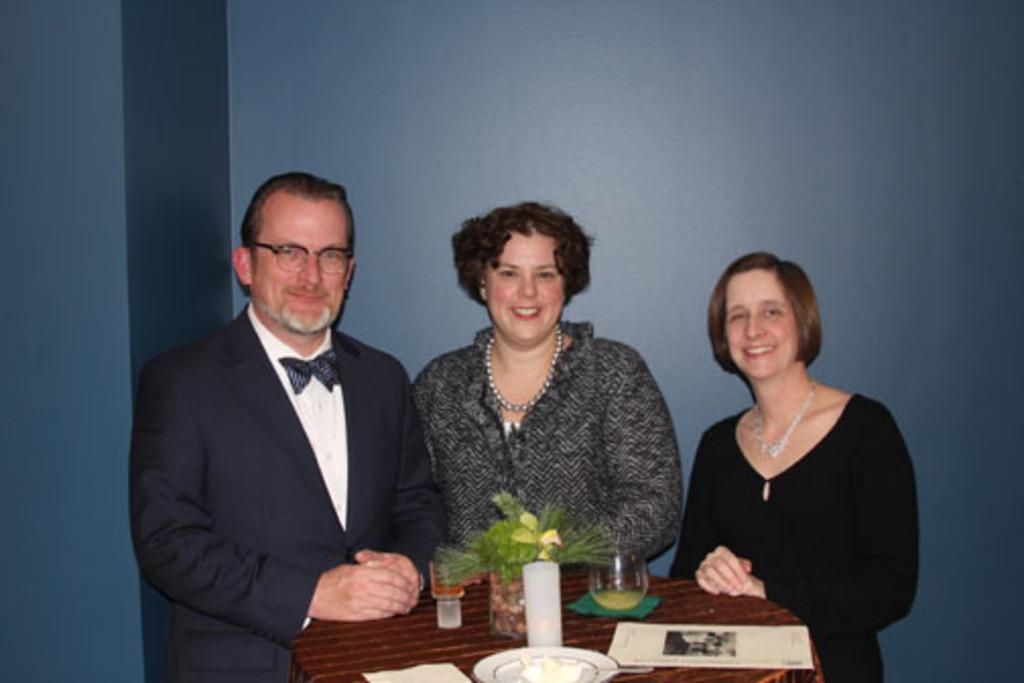What piece of furniture is present in the image? There is a table in the image. What object can be seen on the table? There is a candle, a glass, and a paper on the table. How many people are in the image? There are three persons in the image. What color is the wall visible in the background? There is a blue color wall in the background. Can you tell me how many donkeys are present in the image? There are no donkeys present in the image. What type of iron object can be seen on the table? There is no iron object present on the table in the image. 